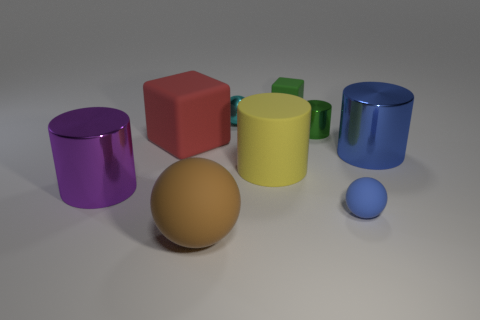Which objects in the image could function as containers and hold liquid? Based on the image, the purple and blue objects appear to be cylindrical cups which could function as containers to hold liquid. They are open at the top and have no visible holes, making them suitable for containing fluids. 